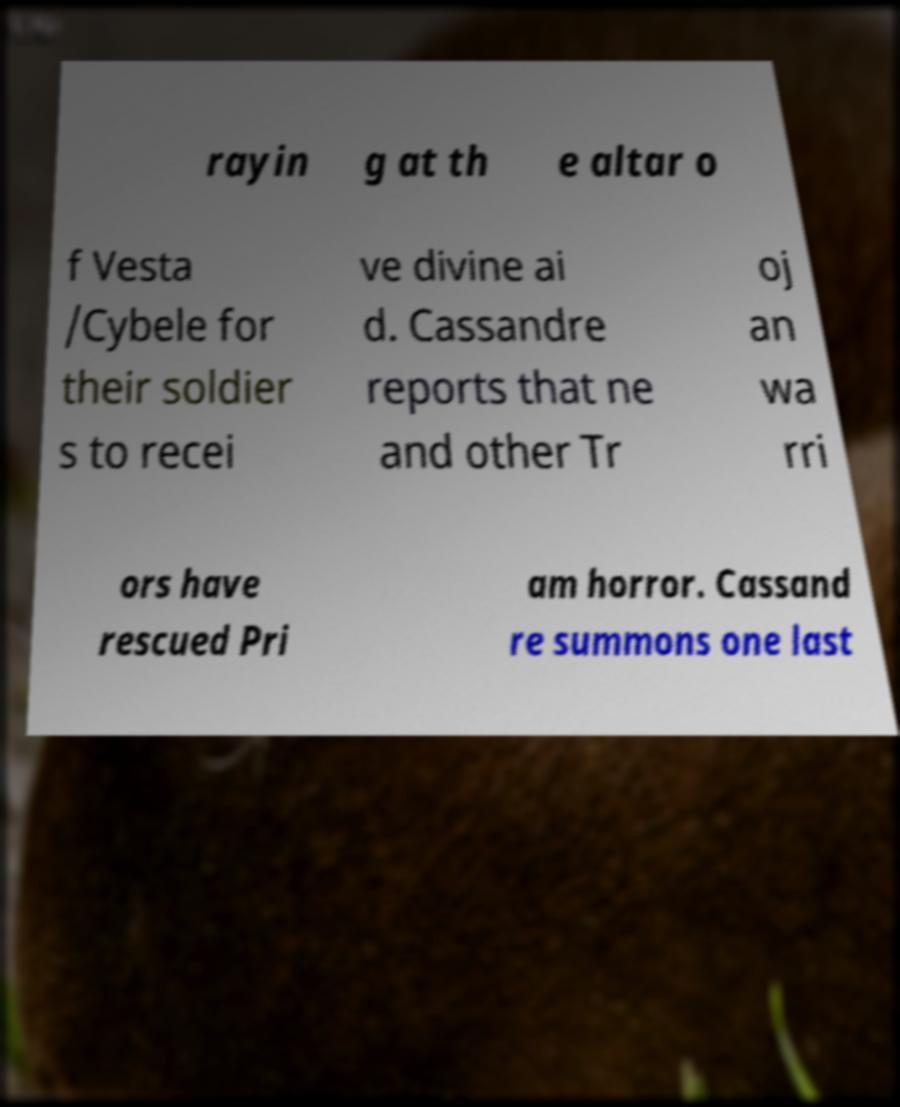Please identify and transcribe the text found in this image. rayin g at th e altar o f Vesta /Cybele for their soldier s to recei ve divine ai d. Cassandre reports that ne and other Tr oj an wa rri ors have rescued Pri am horror. Cassand re summons one last 